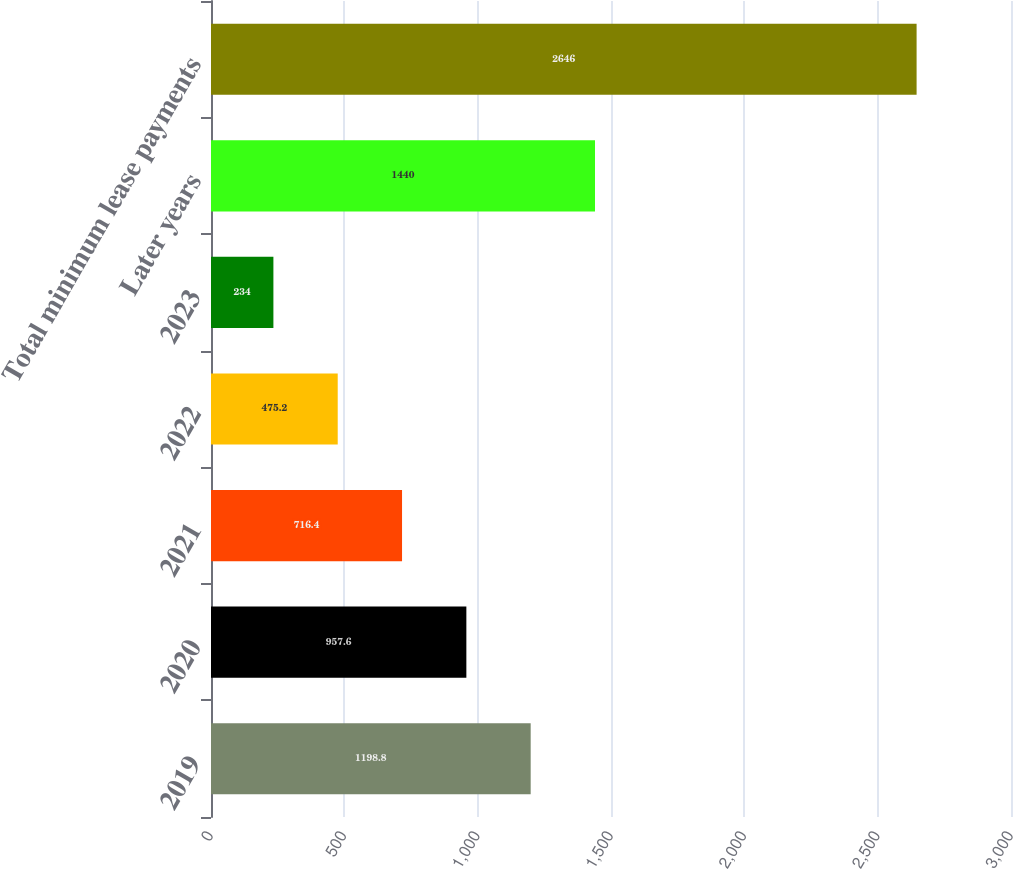<chart> <loc_0><loc_0><loc_500><loc_500><bar_chart><fcel>2019<fcel>2020<fcel>2021<fcel>2022<fcel>2023<fcel>Later years<fcel>Total minimum lease payments<nl><fcel>1198.8<fcel>957.6<fcel>716.4<fcel>475.2<fcel>234<fcel>1440<fcel>2646<nl></chart> 